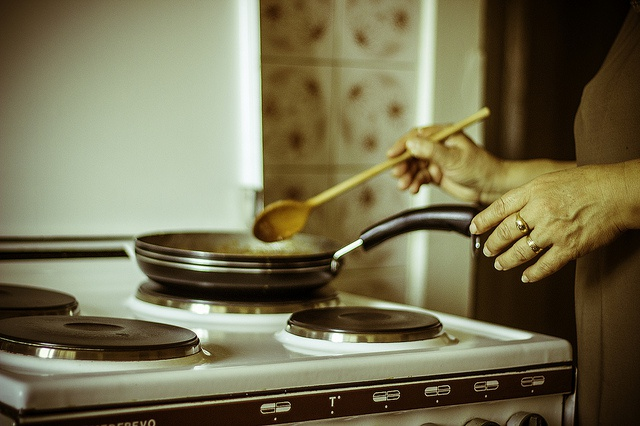Describe the objects in this image and their specific colors. I can see oven in black, gray, darkgray, and olive tones, people in black, olive, and maroon tones, and spoon in black, olive, and maroon tones in this image. 